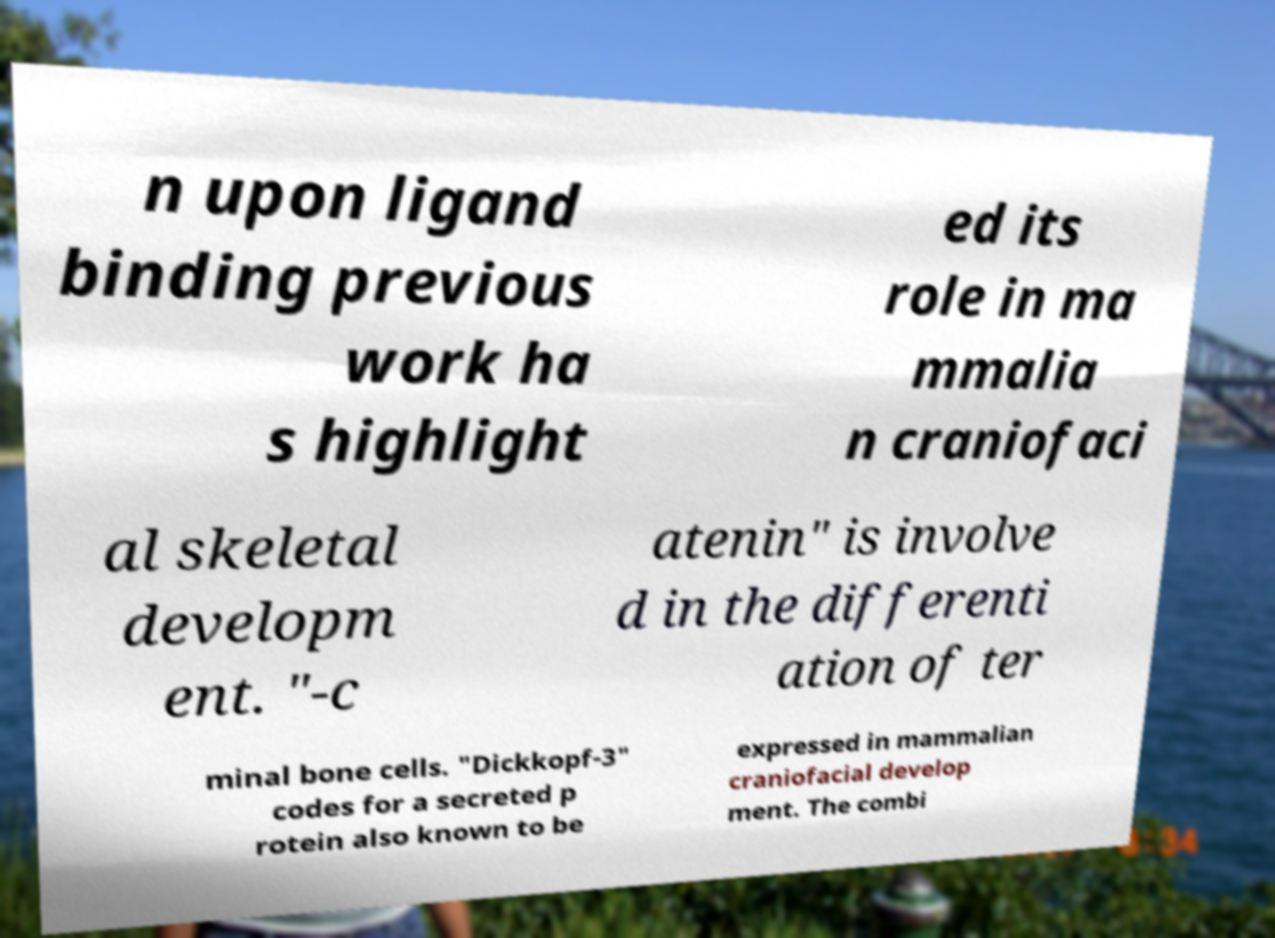I need the written content from this picture converted into text. Can you do that? n upon ligand binding previous work ha s highlight ed its role in ma mmalia n craniofaci al skeletal developm ent. "-c atenin" is involve d in the differenti ation of ter minal bone cells. "Dickkopf-3" codes for a secreted p rotein also known to be expressed in mammalian craniofacial develop ment. The combi 